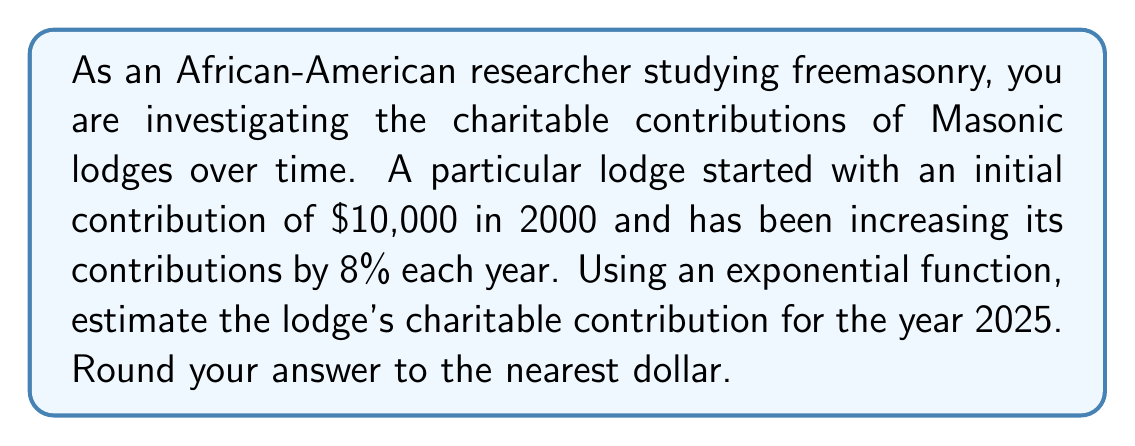What is the answer to this math problem? To solve this problem, we'll use the exponential growth formula:

$$A = P(1 + r)^t$$

Where:
$A$ = Final amount
$P$ = Initial principal balance
$r$ = Annual growth rate (as a decimal)
$t$ = Number of years

Given:
$P = 10,000$ (initial contribution in 2000)
$r = 0.08$ (8% annual increase)
$t = 25$ (number of years from 2000 to 2025)

Let's substitute these values into our formula:

$$A = 10,000(1 + 0.08)^{25}$$

Now we can calculate:

$$A = 10,000(1.08)^{25}$$
$$A = 10,000(6.8484755)$$
$$A = 68,484.755$$

Rounding to the nearest dollar:

$$A ≈ 68,485$$
Answer: $68,485 